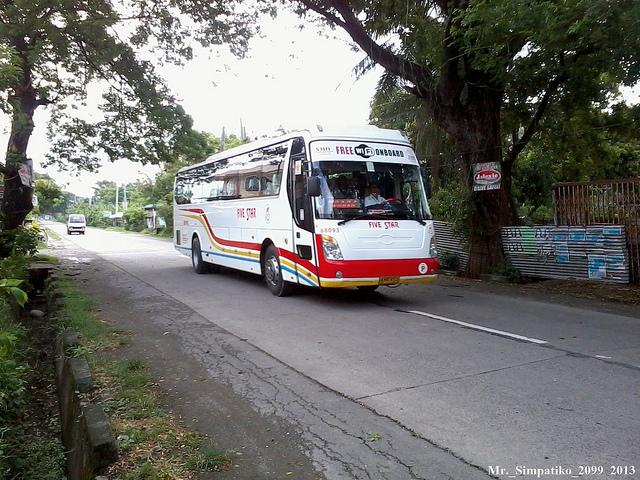What color is the front bus?
Short answer required. White and red. Is the bus driving down the middle of the road?
Quick response, please. Yes. Is it raining out?
Write a very short answer. No. How many buses are there?
Write a very short answer. 1. 